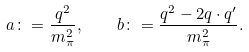<formula> <loc_0><loc_0><loc_500><loc_500>a \colon = \frac { q ^ { 2 } } { m ^ { 2 } _ { \pi } } , \quad b \colon = \frac { q ^ { 2 } - 2 q \cdot q ^ { \prime } } { m ^ { 2 } _ { \pi } } .</formula> 